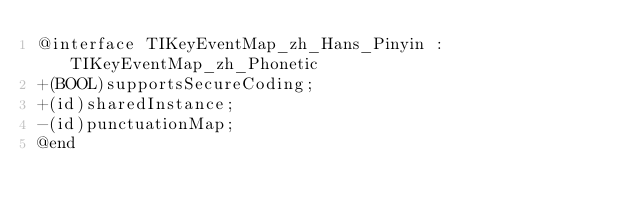<code> <loc_0><loc_0><loc_500><loc_500><_C_>@interface TIKeyEventMap_zh_Hans_Pinyin : TIKeyEventMap_zh_Phonetic
+(BOOL)supportsSecureCoding;
+(id)sharedInstance;
-(id)punctuationMap;
@end

</code> 